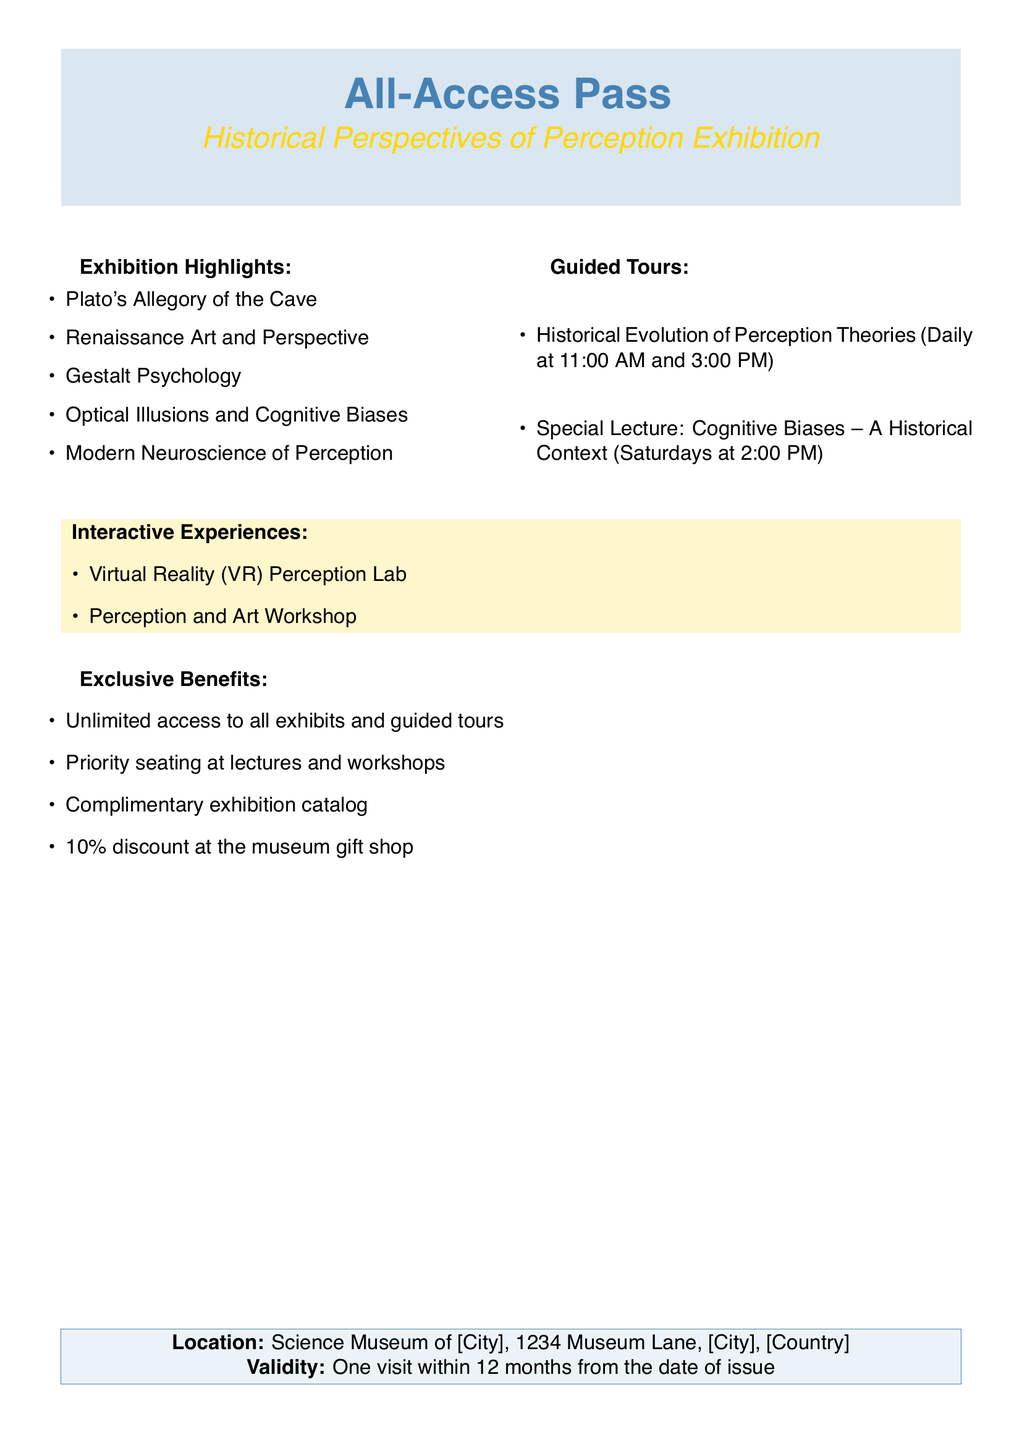What is the title of the exhibition? The title of the exhibition is mentioned at the top of the document following "All-Access Pass."
Answer: Historical Perspectives of Perception Exhibition What benefits do visitors receive? The document outlines exclusive benefits for visitors, such as discounts and catalog access.
Answer: Unlimited access to all exhibits and guided tours What are the daily guided tour times? The document specifies the daily times for guided tours under "Guided Tours."
Answer: 11:00 AM and 3:00 PM Where is the exhibition located? The location of the exhibition is found in the "Location" section of the document.
Answer: Science Museum of [City], 1234 Museum Lane, [City], [Country] What interactive experience is available? The document lists interactive experiences available for visitors.
Answer: Virtual Reality (VR) Perception Lab 